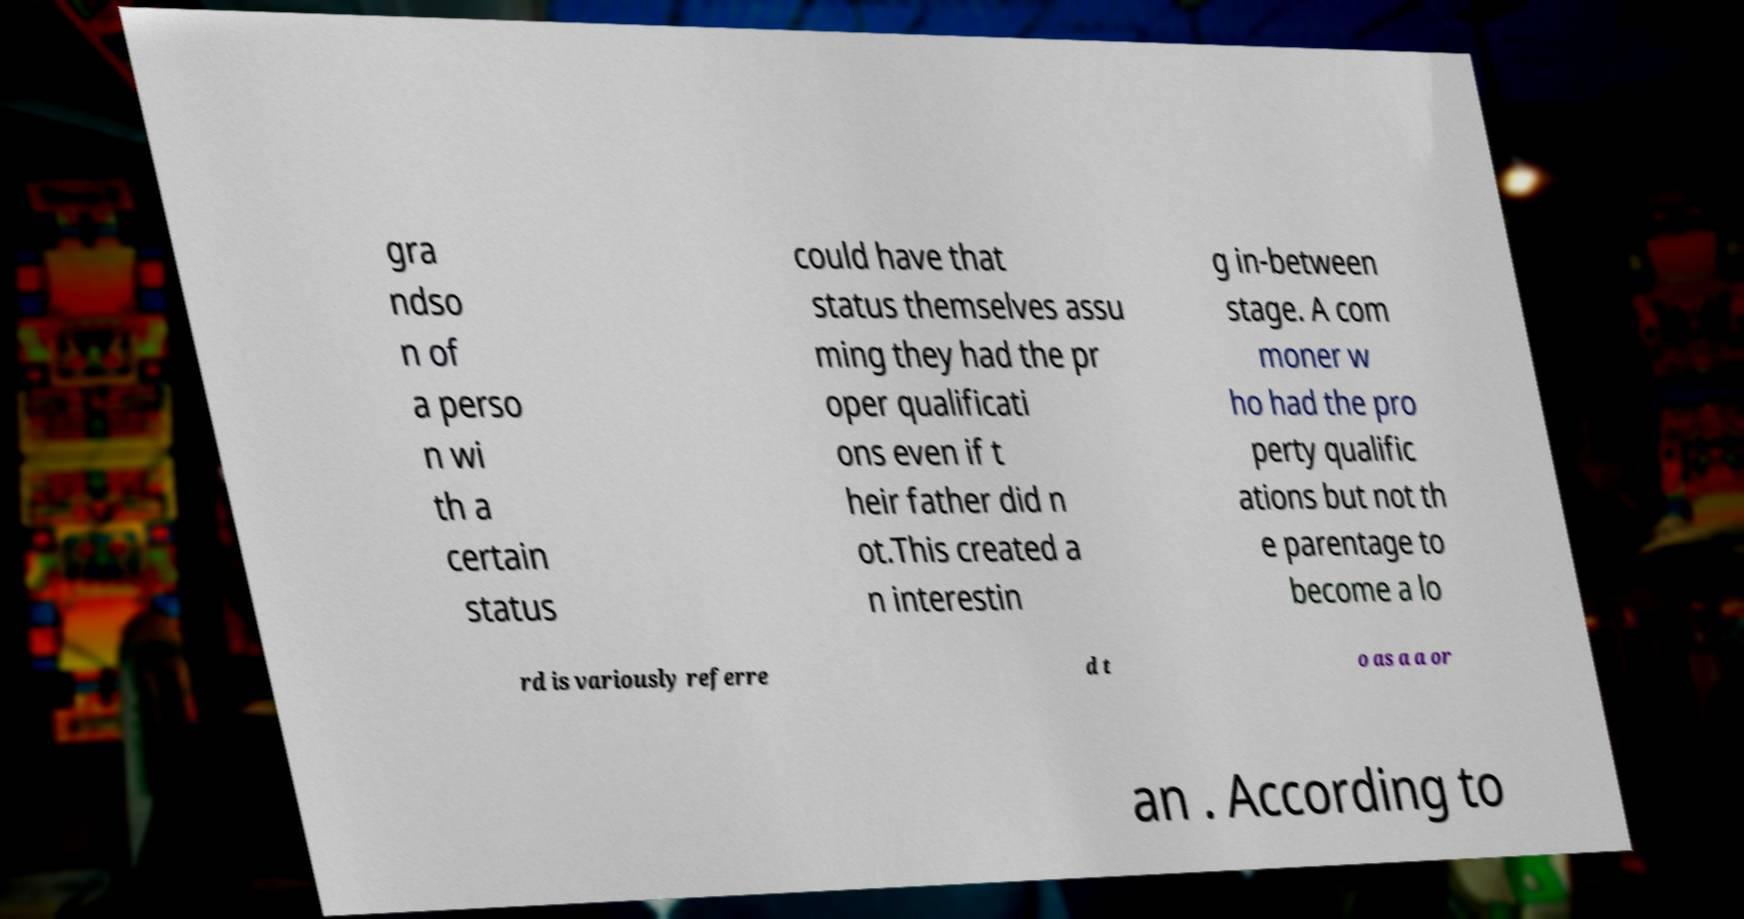What messages or text are displayed in this image? I need them in a readable, typed format. gra ndso n of a perso n wi th a certain status could have that status themselves assu ming they had the pr oper qualificati ons even if t heir father did n ot.This created a n interestin g in-between stage. A com moner w ho had the pro perty qualific ations but not th e parentage to become a lo rd is variously referre d t o as a a or an . According to 